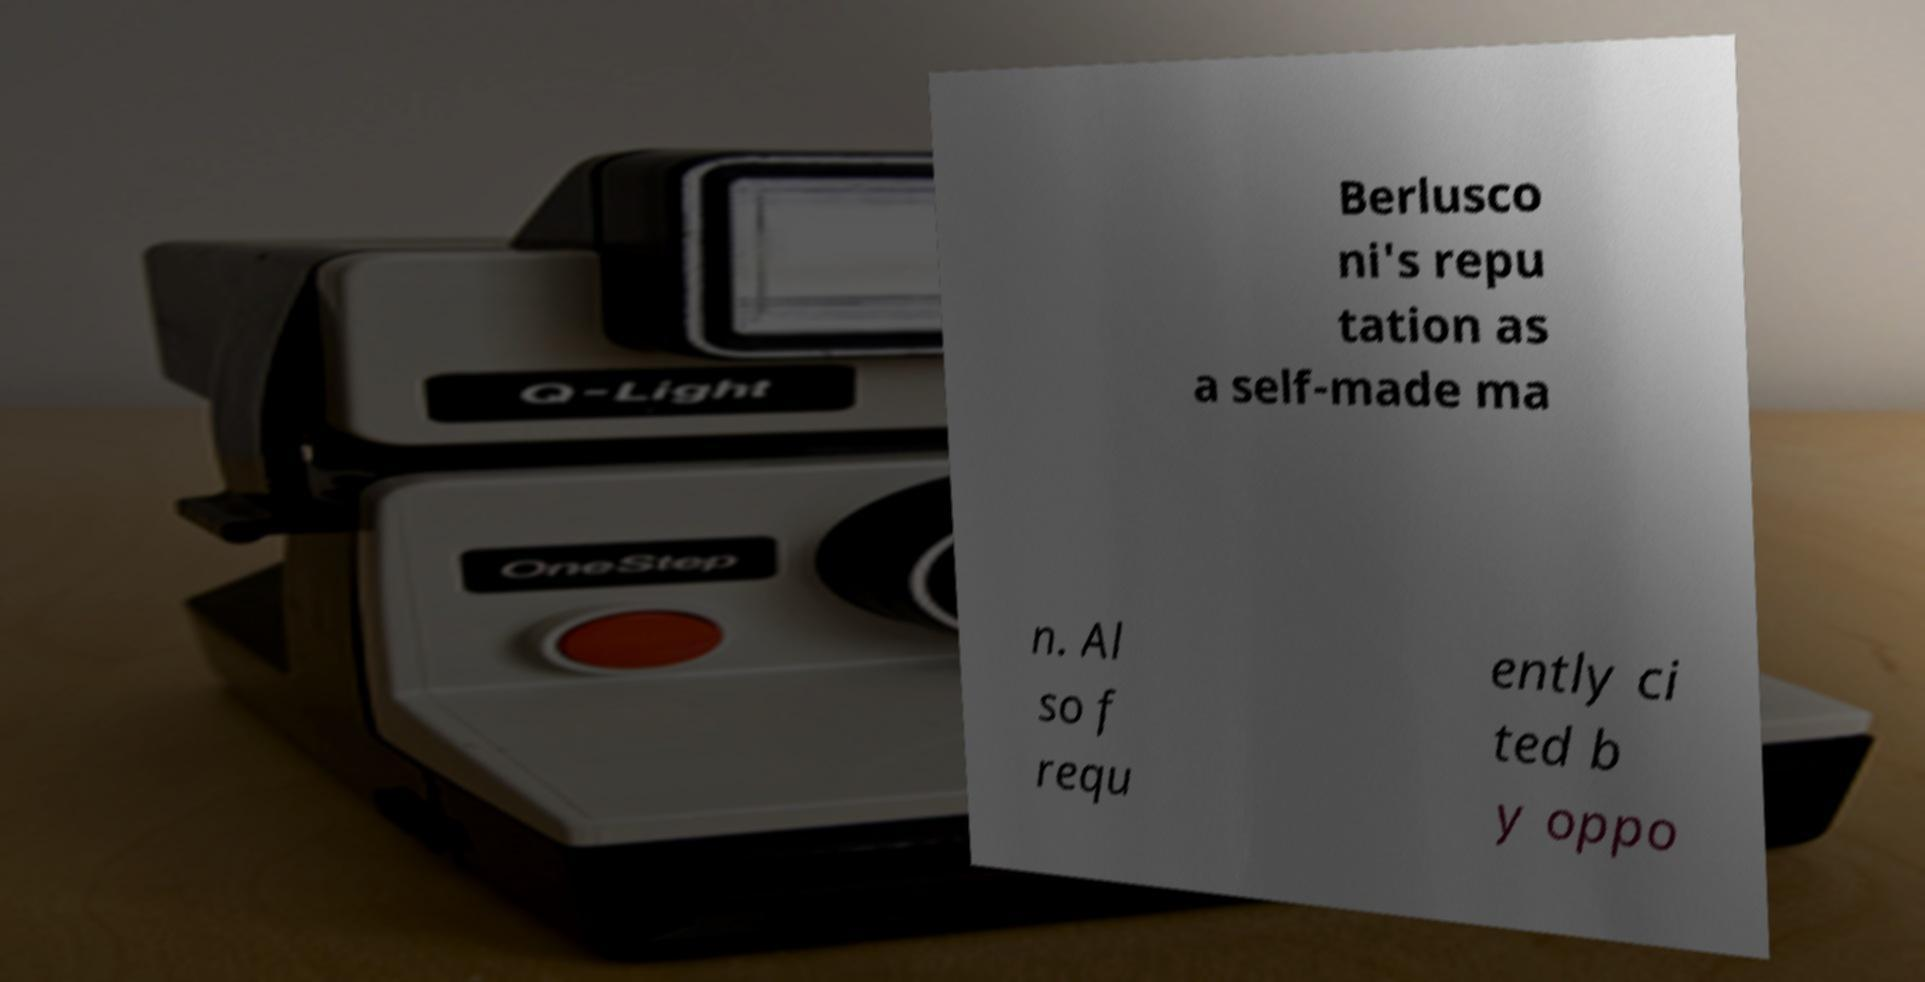Can you accurately transcribe the text from the provided image for me? Berlusco ni's repu tation as a self-made ma n. Al so f requ ently ci ted b y oppo 